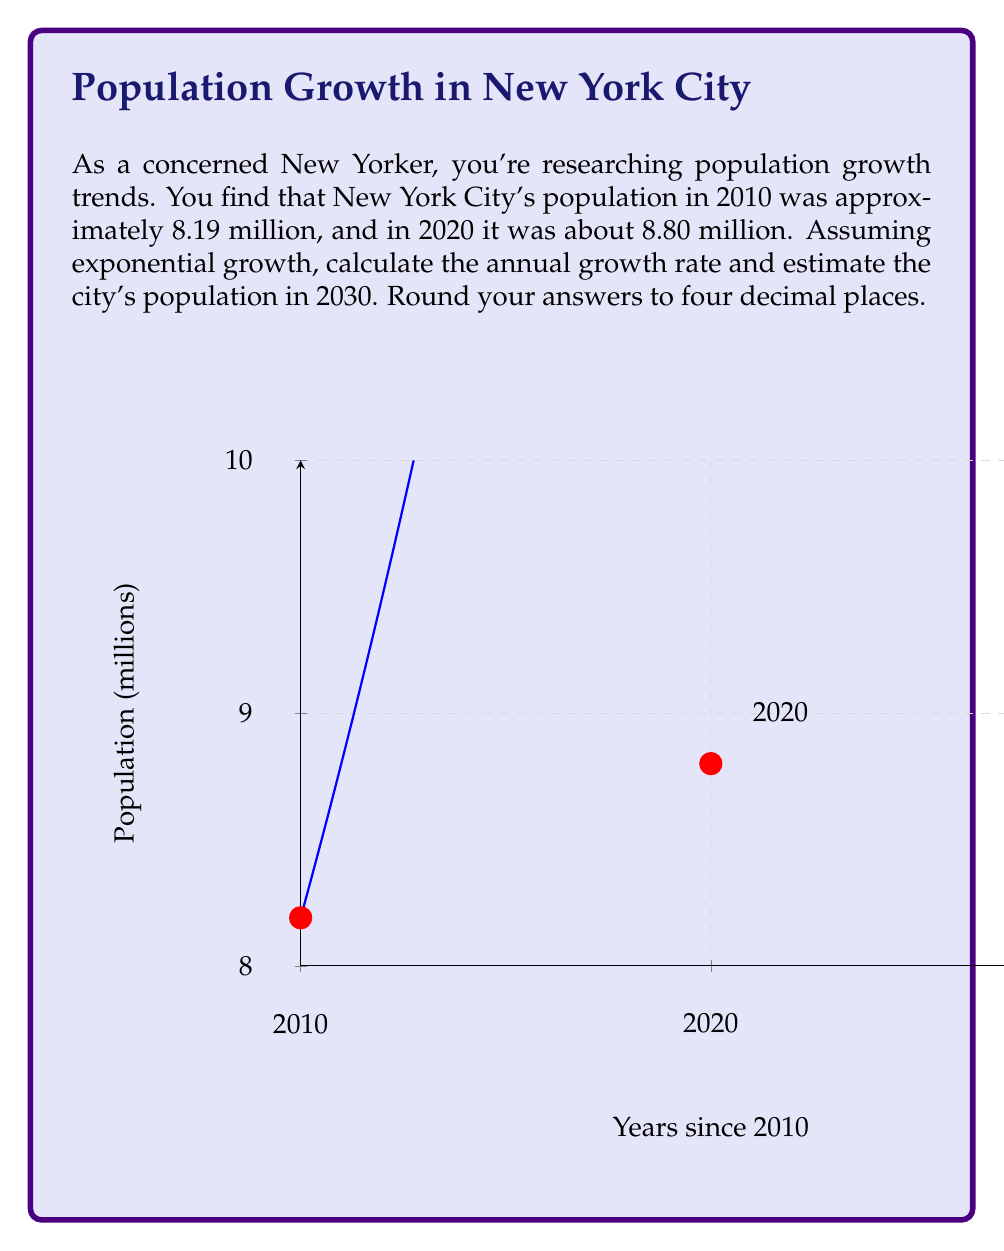Teach me how to tackle this problem. Let's approach this step-by-step using the exponential growth model:

1) The exponential growth formula is $P(t) = P_0 e^{rt}$, where:
   $P(t)$ is the population at time $t$
   $P_0$ is the initial population
   $r$ is the growth rate
   $t$ is the time elapsed

2) We know:
   $P_0 = 8.19$ million (2010 population)
   $P(10) = 8.80$ million (2020 population, 10 years later)

3) Let's plug these into our formula:
   $8.80 = 8.19 e^{10r}$

4) Solving for $r$:
   $\frac{8.80}{8.19} = e^{10r}$
   $\ln(\frac{8.80}{8.19}) = 10r$
   $r = \frac{1}{10} \ln(\frac{8.80}{8.19}) \approx 0.0072$ or about 0.72% per year

5) Now that we have $r$, we can estimate the 2030 population:
   $P(20) = 8.19 e^{20(0.0072)} \approx 9.4615$ million

Therefore, the annual growth rate is approximately 0.0072 or 0.72%, and the estimated 2030 population is about 9.4615 million.
Answer: Annual growth rate: 0.0072; 2030 population estimate: 9.4615 million 